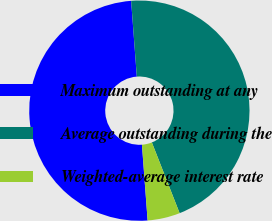Convert chart. <chart><loc_0><loc_0><loc_500><loc_500><pie_chart><fcel>Maximum outstanding at any<fcel>Average outstanding during the<fcel>Weighted-average interest rate<nl><fcel>50.0%<fcel>45.24%<fcel>4.76%<nl></chart> 